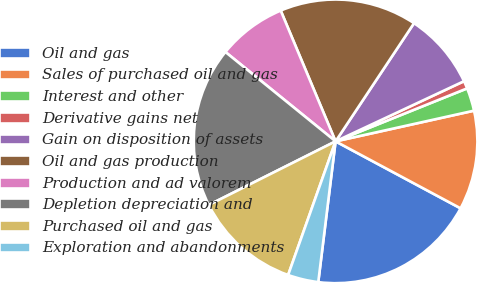Convert chart to OTSL. <chart><loc_0><loc_0><loc_500><loc_500><pie_chart><fcel>Oil and gas<fcel>Sales of purchased oil and gas<fcel>Interest and other<fcel>Derivative gains net<fcel>Gain on disposition of assets<fcel>Oil and gas production<fcel>Production and ad valorem<fcel>Depletion depreciation and<fcel>Purchased oil and gas<fcel>Exploration and abandonments<nl><fcel>19.12%<fcel>11.3%<fcel>2.62%<fcel>0.88%<fcel>8.7%<fcel>15.65%<fcel>7.83%<fcel>18.25%<fcel>12.17%<fcel>3.48%<nl></chart> 